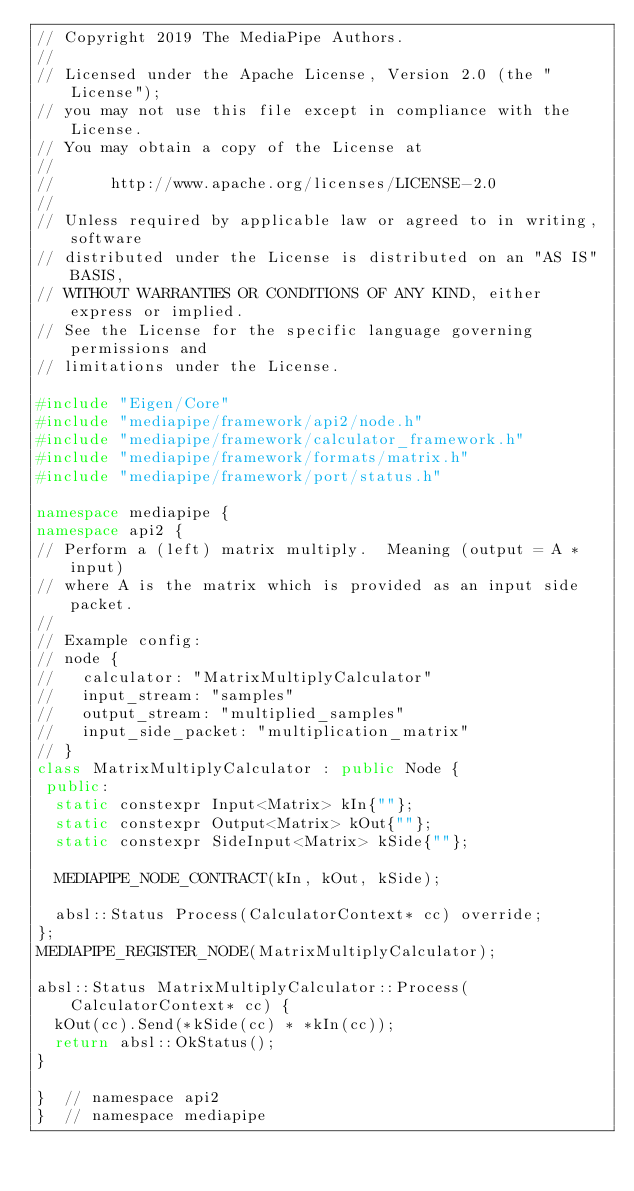<code> <loc_0><loc_0><loc_500><loc_500><_C++_>// Copyright 2019 The MediaPipe Authors.
//
// Licensed under the Apache License, Version 2.0 (the "License");
// you may not use this file except in compliance with the License.
// You may obtain a copy of the License at
//
//      http://www.apache.org/licenses/LICENSE-2.0
//
// Unless required by applicable law or agreed to in writing, software
// distributed under the License is distributed on an "AS IS" BASIS,
// WITHOUT WARRANTIES OR CONDITIONS OF ANY KIND, either express or implied.
// See the License for the specific language governing permissions and
// limitations under the License.

#include "Eigen/Core"
#include "mediapipe/framework/api2/node.h"
#include "mediapipe/framework/calculator_framework.h"
#include "mediapipe/framework/formats/matrix.h"
#include "mediapipe/framework/port/status.h"

namespace mediapipe {
namespace api2 {
// Perform a (left) matrix multiply.  Meaning (output = A * input)
// where A is the matrix which is provided as an input side packet.
//
// Example config:
// node {
//   calculator: "MatrixMultiplyCalculator"
//   input_stream: "samples"
//   output_stream: "multiplied_samples"
//   input_side_packet: "multiplication_matrix"
// }
class MatrixMultiplyCalculator : public Node {
 public:
  static constexpr Input<Matrix> kIn{""};
  static constexpr Output<Matrix> kOut{""};
  static constexpr SideInput<Matrix> kSide{""};

  MEDIAPIPE_NODE_CONTRACT(kIn, kOut, kSide);

  absl::Status Process(CalculatorContext* cc) override;
};
MEDIAPIPE_REGISTER_NODE(MatrixMultiplyCalculator);

absl::Status MatrixMultiplyCalculator::Process(CalculatorContext* cc) {
  kOut(cc).Send(*kSide(cc) * *kIn(cc));
  return absl::OkStatus();
}

}  // namespace api2
}  // namespace mediapipe
</code> 